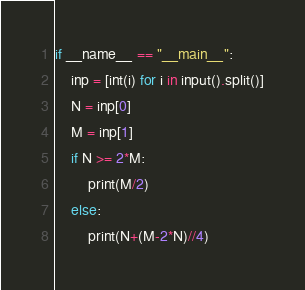Convert code to text. <code><loc_0><loc_0><loc_500><loc_500><_Python_>if __name__ == "__main__":
    inp = [int(i) for i in input().split()]
    N = inp[0]
    M = inp[1]
    if N >= 2*M:
        print(M/2)
    else:
        print(N+(M-2*N)//4)</code> 